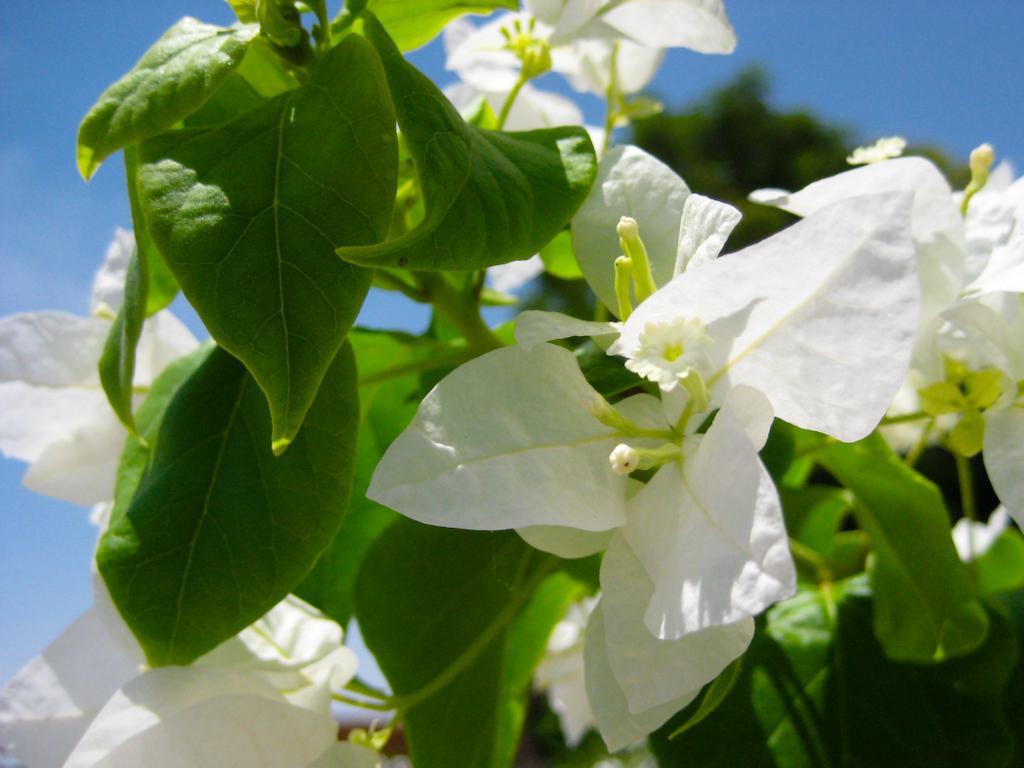How would you summarize this image in a sentence or two? In the image we can see there are white colour flowers on the plant and there is a clear sky. Background of the image is little blurred. 